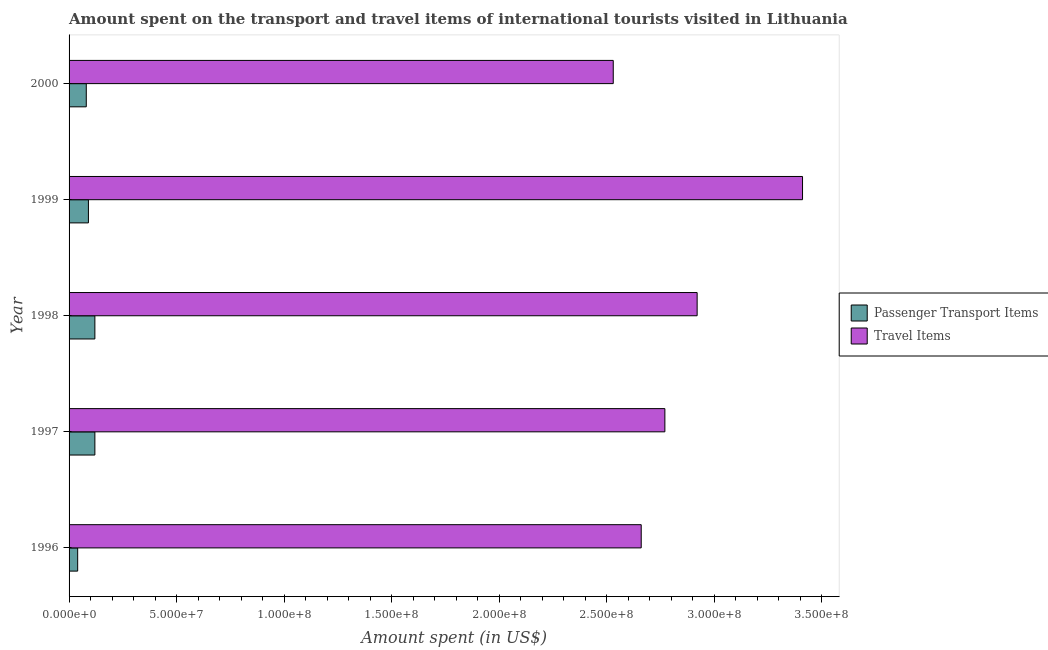How many different coloured bars are there?
Your answer should be very brief. 2. How many groups of bars are there?
Your answer should be compact. 5. Are the number of bars on each tick of the Y-axis equal?
Provide a succinct answer. Yes. How many bars are there on the 2nd tick from the top?
Provide a short and direct response. 2. What is the label of the 3rd group of bars from the top?
Keep it short and to the point. 1998. What is the amount spent in travel items in 1996?
Your answer should be very brief. 2.66e+08. Across all years, what is the maximum amount spent in travel items?
Offer a very short reply. 3.41e+08. Across all years, what is the minimum amount spent in travel items?
Offer a terse response. 2.53e+08. What is the total amount spent on passenger transport items in the graph?
Keep it short and to the point. 4.50e+07. What is the difference between the amount spent on passenger transport items in 1998 and that in 1999?
Offer a very short reply. 3.00e+06. What is the difference between the amount spent on passenger transport items in 1999 and the amount spent in travel items in 1998?
Your response must be concise. -2.83e+08. What is the average amount spent in travel items per year?
Give a very brief answer. 2.86e+08. In the year 1999, what is the difference between the amount spent on passenger transport items and amount spent in travel items?
Keep it short and to the point. -3.32e+08. What is the ratio of the amount spent in travel items in 1997 to that in 1998?
Provide a succinct answer. 0.95. Is the amount spent in travel items in 1998 less than that in 1999?
Your answer should be very brief. Yes. Is the difference between the amount spent on passenger transport items in 1996 and 1997 greater than the difference between the amount spent in travel items in 1996 and 1997?
Your answer should be very brief. Yes. What is the difference between the highest and the second highest amount spent in travel items?
Offer a terse response. 4.90e+07. What is the difference between the highest and the lowest amount spent in travel items?
Keep it short and to the point. 8.80e+07. Is the sum of the amount spent in travel items in 1998 and 1999 greater than the maximum amount spent on passenger transport items across all years?
Ensure brevity in your answer.  Yes. What does the 1st bar from the top in 1996 represents?
Keep it short and to the point. Travel Items. What does the 1st bar from the bottom in 1998 represents?
Your response must be concise. Passenger Transport Items. How many bars are there?
Your answer should be compact. 10. What is the difference between two consecutive major ticks on the X-axis?
Keep it short and to the point. 5.00e+07. Does the graph contain grids?
Give a very brief answer. No. How many legend labels are there?
Keep it short and to the point. 2. How are the legend labels stacked?
Make the answer very short. Vertical. What is the title of the graph?
Make the answer very short. Amount spent on the transport and travel items of international tourists visited in Lithuania. What is the label or title of the X-axis?
Provide a succinct answer. Amount spent (in US$). What is the label or title of the Y-axis?
Your response must be concise. Year. What is the Amount spent (in US$) of Travel Items in 1996?
Offer a terse response. 2.66e+08. What is the Amount spent (in US$) in Travel Items in 1997?
Make the answer very short. 2.77e+08. What is the Amount spent (in US$) in Travel Items in 1998?
Ensure brevity in your answer.  2.92e+08. What is the Amount spent (in US$) of Passenger Transport Items in 1999?
Give a very brief answer. 9.00e+06. What is the Amount spent (in US$) in Travel Items in 1999?
Make the answer very short. 3.41e+08. What is the Amount spent (in US$) of Passenger Transport Items in 2000?
Offer a terse response. 8.00e+06. What is the Amount spent (in US$) in Travel Items in 2000?
Keep it short and to the point. 2.53e+08. Across all years, what is the maximum Amount spent (in US$) in Travel Items?
Make the answer very short. 3.41e+08. Across all years, what is the minimum Amount spent (in US$) of Passenger Transport Items?
Give a very brief answer. 4.00e+06. Across all years, what is the minimum Amount spent (in US$) in Travel Items?
Offer a very short reply. 2.53e+08. What is the total Amount spent (in US$) in Passenger Transport Items in the graph?
Make the answer very short. 4.50e+07. What is the total Amount spent (in US$) of Travel Items in the graph?
Offer a very short reply. 1.43e+09. What is the difference between the Amount spent (in US$) in Passenger Transport Items in 1996 and that in 1997?
Ensure brevity in your answer.  -8.00e+06. What is the difference between the Amount spent (in US$) of Travel Items in 1996 and that in 1997?
Ensure brevity in your answer.  -1.10e+07. What is the difference between the Amount spent (in US$) of Passenger Transport Items in 1996 and that in 1998?
Provide a short and direct response. -8.00e+06. What is the difference between the Amount spent (in US$) of Travel Items in 1996 and that in 1998?
Give a very brief answer. -2.60e+07. What is the difference between the Amount spent (in US$) of Passenger Transport Items in 1996 and that in 1999?
Make the answer very short. -5.00e+06. What is the difference between the Amount spent (in US$) of Travel Items in 1996 and that in 1999?
Make the answer very short. -7.50e+07. What is the difference between the Amount spent (in US$) in Travel Items in 1996 and that in 2000?
Your answer should be compact. 1.30e+07. What is the difference between the Amount spent (in US$) in Passenger Transport Items in 1997 and that in 1998?
Offer a terse response. 0. What is the difference between the Amount spent (in US$) in Travel Items in 1997 and that in 1998?
Keep it short and to the point. -1.50e+07. What is the difference between the Amount spent (in US$) of Passenger Transport Items in 1997 and that in 1999?
Offer a terse response. 3.00e+06. What is the difference between the Amount spent (in US$) in Travel Items in 1997 and that in 1999?
Your answer should be compact. -6.40e+07. What is the difference between the Amount spent (in US$) in Passenger Transport Items in 1997 and that in 2000?
Make the answer very short. 4.00e+06. What is the difference between the Amount spent (in US$) in Travel Items in 1997 and that in 2000?
Offer a very short reply. 2.40e+07. What is the difference between the Amount spent (in US$) of Passenger Transport Items in 1998 and that in 1999?
Offer a very short reply. 3.00e+06. What is the difference between the Amount spent (in US$) in Travel Items in 1998 and that in 1999?
Make the answer very short. -4.90e+07. What is the difference between the Amount spent (in US$) of Passenger Transport Items in 1998 and that in 2000?
Offer a terse response. 4.00e+06. What is the difference between the Amount spent (in US$) of Travel Items in 1998 and that in 2000?
Offer a very short reply. 3.90e+07. What is the difference between the Amount spent (in US$) in Travel Items in 1999 and that in 2000?
Provide a short and direct response. 8.80e+07. What is the difference between the Amount spent (in US$) of Passenger Transport Items in 1996 and the Amount spent (in US$) of Travel Items in 1997?
Provide a short and direct response. -2.73e+08. What is the difference between the Amount spent (in US$) of Passenger Transport Items in 1996 and the Amount spent (in US$) of Travel Items in 1998?
Offer a very short reply. -2.88e+08. What is the difference between the Amount spent (in US$) of Passenger Transport Items in 1996 and the Amount spent (in US$) of Travel Items in 1999?
Ensure brevity in your answer.  -3.37e+08. What is the difference between the Amount spent (in US$) of Passenger Transport Items in 1996 and the Amount spent (in US$) of Travel Items in 2000?
Ensure brevity in your answer.  -2.49e+08. What is the difference between the Amount spent (in US$) in Passenger Transport Items in 1997 and the Amount spent (in US$) in Travel Items in 1998?
Your response must be concise. -2.80e+08. What is the difference between the Amount spent (in US$) of Passenger Transport Items in 1997 and the Amount spent (in US$) of Travel Items in 1999?
Ensure brevity in your answer.  -3.29e+08. What is the difference between the Amount spent (in US$) in Passenger Transport Items in 1997 and the Amount spent (in US$) in Travel Items in 2000?
Ensure brevity in your answer.  -2.41e+08. What is the difference between the Amount spent (in US$) in Passenger Transport Items in 1998 and the Amount spent (in US$) in Travel Items in 1999?
Keep it short and to the point. -3.29e+08. What is the difference between the Amount spent (in US$) in Passenger Transport Items in 1998 and the Amount spent (in US$) in Travel Items in 2000?
Provide a short and direct response. -2.41e+08. What is the difference between the Amount spent (in US$) of Passenger Transport Items in 1999 and the Amount spent (in US$) of Travel Items in 2000?
Ensure brevity in your answer.  -2.44e+08. What is the average Amount spent (in US$) in Passenger Transport Items per year?
Make the answer very short. 9.00e+06. What is the average Amount spent (in US$) of Travel Items per year?
Keep it short and to the point. 2.86e+08. In the year 1996, what is the difference between the Amount spent (in US$) in Passenger Transport Items and Amount spent (in US$) in Travel Items?
Keep it short and to the point. -2.62e+08. In the year 1997, what is the difference between the Amount spent (in US$) in Passenger Transport Items and Amount spent (in US$) in Travel Items?
Provide a succinct answer. -2.65e+08. In the year 1998, what is the difference between the Amount spent (in US$) in Passenger Transport Items and Amount spent (in US$) in Travel Items?
Ensure brevity in your answer.  -2.80e+08. In the year 1999, what is the difference between the Amount spent (in US$) of Passenger Transport Items and Amount spent (in US$) of Travel Items?
Offer a very short reply. -3.32e+08. In the year 2000, what is the difference between the Amount spent (in US$) in Passenger Transport Items and Amount spent (in US$) in Travel Items?
Make the answer very short. -2.45e+08. What is the ratio of the Amount spent (in US$) of Passenger Transport Items in 1996 to that in 1997?
Give a very brief answer. 0.33. What is the ratio of the Amount spent (in US$) in Travel Items in 1996 to that in 1997?
Your answer should be very brief. 0.96. What is the ratio of the Amount spent (in US$) of Travel Items in 1996 to that in 1998?
Your answer should be compact. 0.91. What is the ratio of the Amount spent (in US$) of Passenger Transport Items in 1996 to that in 1999?
Your response must be concise. 0.44. What is the ratio of the Amount spent (in US$) in Travel Items in 1996 to that in 1999?
Offer a very short reply. 0.78. What is the ratio of the Amount spent (in US$) in Passenger Transport Items in 1996 to that in 2000?
Provide a succinct answer. 0.5. What is the ratio of the Amount spent (in US$) in Travel Items in 1996 to that in 2000?
Offer a very short reply. 1.05. What is the ratio of the Amount spent (in US$) in Travel Items in 1997 to that in 1998?
Your answer should be very brief. 0.95. What is the ratio of the Amount spent (in US$) of Passenger Transport Items in 1997 to that in 1999?
Your answer should be very brief. 1.33. What is the ratio of the Amount spent (in US$) of Travel Items in 1997 to that in 1999?
Ensure brevity in your answer.  0.81. What is the ratio of the Amount spent (in US$) of Passenger Transport Items in 1997 to that in 2000?
Ensure brevity in your answer.  1.5. What is the ratio of the Amount spent (in US$) in Travel Items in 1997 to that in 2000?
Offer a very short reply. 1.09. What is the ratio of the Amount spent (in US$) of Passenger Transport Items in 1998 to that in 1999?
Keep it short and to the point. 1.33. What is the ratio of the Amount spent (in US$) in Travel Items in 1998 to that in 1999?
Your answer should be very brief. 0.86. What is the ratio of the Amount spent (in US$) in Travel Items in 1998 to that in 2000?
Your answer should be very brief. 1.15. What is the ratio of the Amount spent (in US$) in Travel Items in 1999 to that in 2000?
Offer a terse response. 1.35. What is the difference between the highest and the second highest Amount spent (in US$) of Travel Items?
Offer a terse response. 4.90e+07. What is the difference between the highest and the lowest Amount spent (in US$) of Passenger Transport Items?
Give a very brief answer. 8.00e+06. What is the difference between the highest and the lowest Amount spent (in US$) in Travel Items?
Your answer should be very brief. 8.80e+07. 